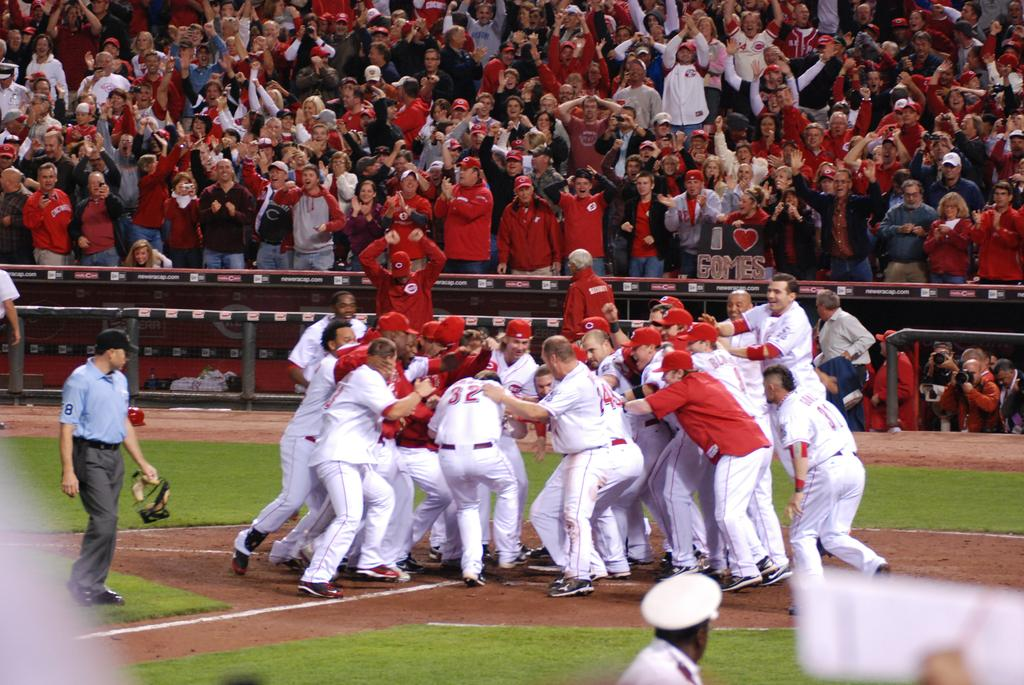Provide a one-sentence caption for the provided image. a group of ball players celebrating and one with the number 32 on. 